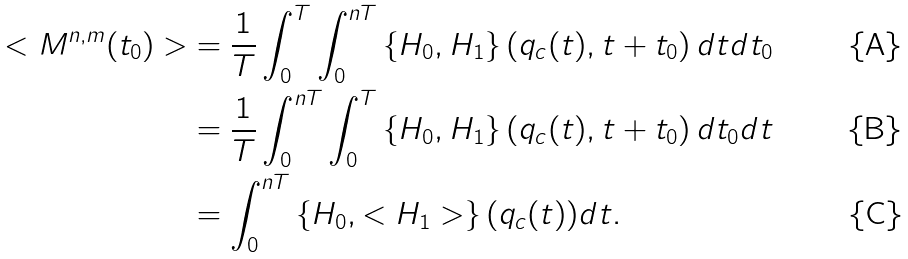<formula> <loc_0><loc_0><loc_500><loc_500>< M ^ { n , m } ( t _ { 0 } ) > & = \frac { 1 } { T } \int _ { 0 } ^ { T } \int _ { 0 } ^ { n T } \left \{ H _ { 0 } , H _ { 1 } \right \} \left ( q _ { c } ( t ) , t + t _ { 0 } \right ) d t d t _ { 0 } \\ & = \frac { 1 } { T } \int _ { 0 } ^ { n T } \int _ { 0 } ^ { T } \left \{ H _ { 0 } , H _ { 1 } \right \} \left ( q _ { c } ( t ) , t + t _ { 0 } \right ) d t _ { 0 } d t \\ & = \int _ { 0 } ^ { n T } \left \{ H _ { 0 } , < H _ { 1 } > \right \} ( q _ { c } ( t ) ) d t .</formula> 